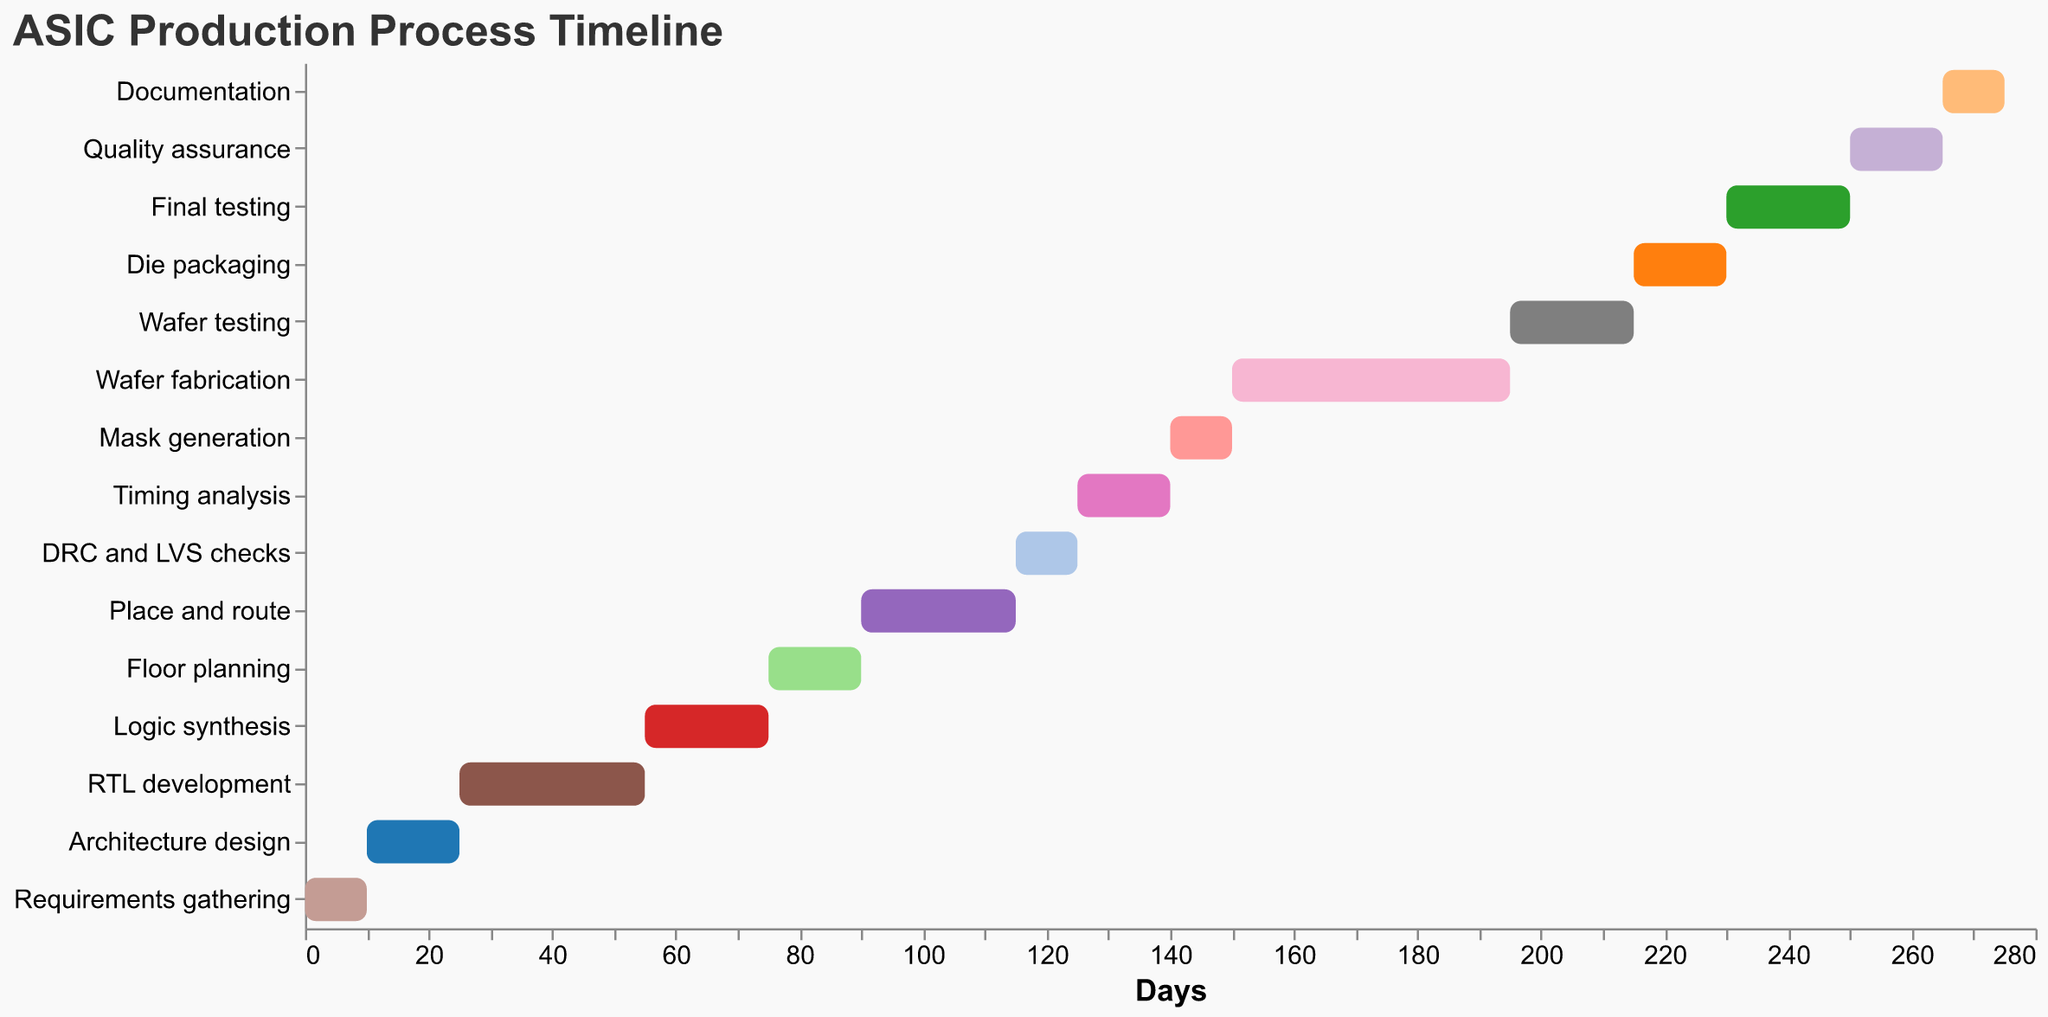What is the duration of the RTL development task? Find the "RTL development" task. The duration is listed directly next to the task.
Answer: 30 days Which tasks have the same duration? Compare the durations listed for each task. "Quality assurance" and "Floor planning" both have a duration of 15 days each.
Answer: Quality assurance, Floor planning What's the difference in start days between "Mask generation" and "Timing analysis"? "Timing analysis" starts at day 125 and "Mask generation" starts at day 140. Calculate the difference: 140 - 125 = 15
Answer: 15 days What is the last task in the Gantt chart? The last task is at the end of the list. The final task is "Documentation."
Answer: Documentation Which tasks take longer than 20 days to complete? Check the duration for each task and identify those longer than 20 days: "RTL development," "Place and route," "Wafer fabrication," and "Final testing."
Answer: RTL development, Place and route, Wafer fabrication, Final testing How long is the entire ASIC production process from start to finish? The first task starts at day 0, and the last task, "Documentation," ends at day 275 (265 + 10). So, the process duration is 275 days.
Answer: 275 days Which task has the shortest duration? Identify the task with the minimum duration value: "DRC and LVS checks" and "Mask generation" both have the shortest duration of 10 days.
Answer: DRC and LVS checks, Mask generation What is the combined duration of "Wafer testing" and "Die packaging"? Add the duration of "Wafer testing" (20 days) and "Die packaging" (15 days): 20 + 15 = 35 days
Answer: 35 days Does "Place and route" start before "Floor planning" ends? If yes, by how many days? "Floor planning" starts on day 75 and lasts 15 days, ending at day 90. "Place and route" starts on day 90. There is no overlap.
Answer: No overlap Which tasks directly follow "Wafer fabrication"? Find the task ending just before "Die packaging" starts. "Wafer testing" immediately follows "Wafer fabrication."
Answer: Wafer testing 